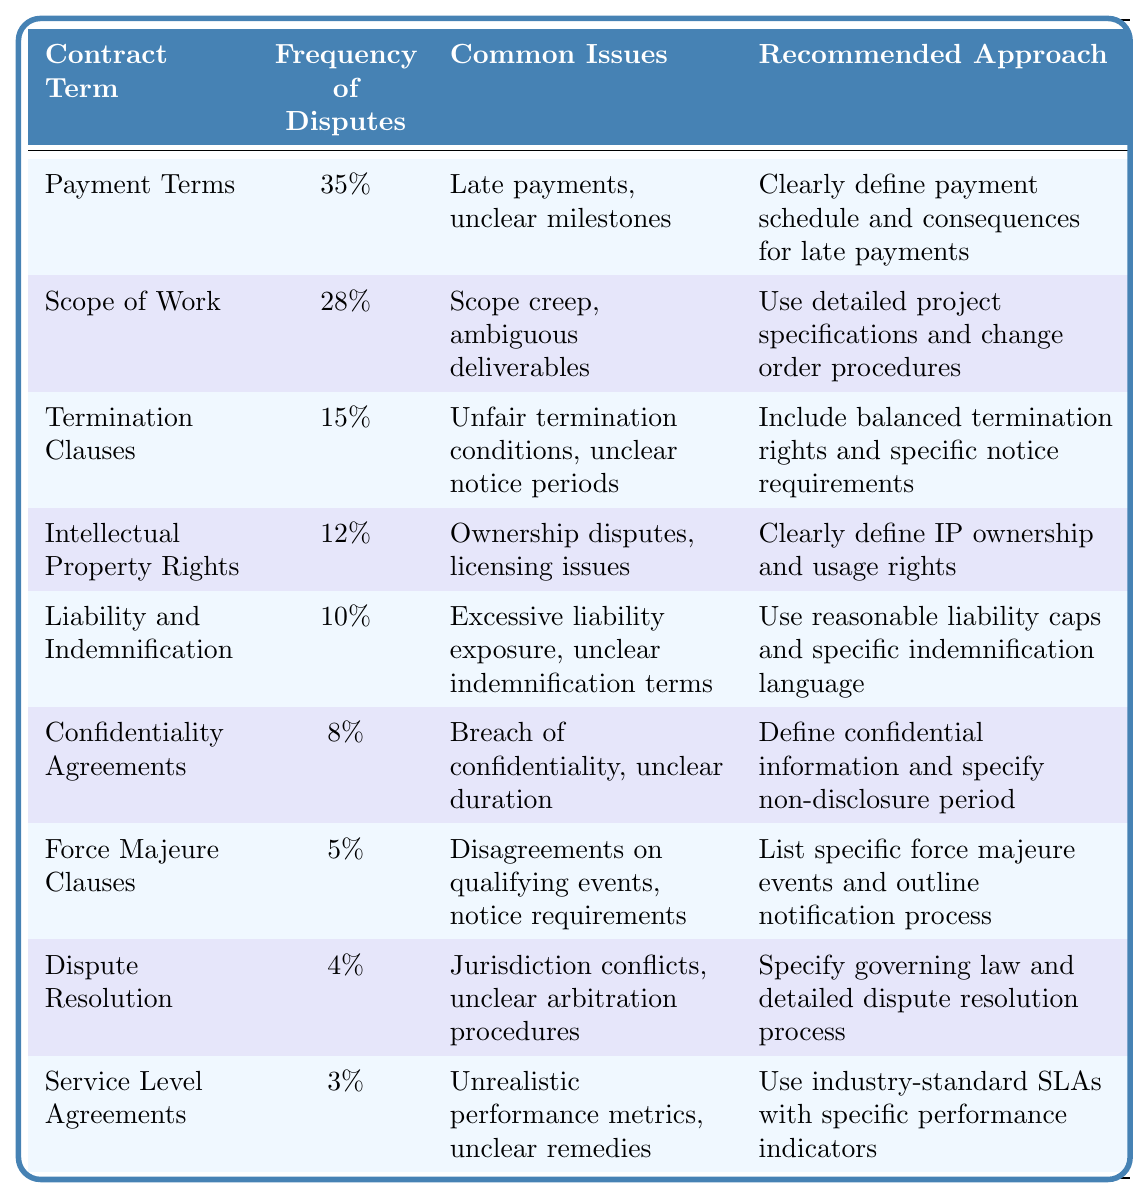What is the most frequently disputed contract term? The table indicates that "Payment Terms" have the highest frequency of disputes at 35%.
Answer: Payment Terms What percentage of disputes are related to Termination Clauses? The table shows that Termination Clauses account for 15% of disputes.
Answer: 15% Which contract term has the lowest frequency of disputes? The table reveals that "Service Level Agreements" has the lowest frequency with only 3%.
Answer: Service Level Agreements What are common issues with Scope of Work? According to the table, the common issues with Scope of Work include scope creep and ambiguous deliverables.
Answer: Scope creep, ambiguous deliverables What is the recommended approach for addressing Intellectual Property Rights disputes? The table recommends clearly defining IP ownership and usage rights to address disputes in this area.
Answer: Clearly define IP ownership and usage rights How do the disputes for Liability and Indemnification compare to those for Confidentiality Agreements? The disputes for Liability and Indemnification account for 10%, while Confidentiality Agreements account for 8%, indicating that Liability and Indemnification disputes are more frequent by 2%.
Answer: 2% more frequent If you sum the frequencies of disputes for all terms listed, what is the total? Adding the percentages: 35% + 28% + 15% + 12% + 10% + 8% + 5% + 4% + 3% equals 120%.
Answer: 120% Which contract term has a recommended approach that includes industry-standard SLAs? The table states that the recommended approach for "Service Level Agreements" includes using industry-standard SLAs with specific performance indicators.
Answer: Service Level Agreements Is the frequency of disputes for Force Majeure Clauses higher than that for Dispute Resolution? Yes, Force Majeure Clauses (5%) have a higher frequency of disputes compared to Dispute Resolution (4%).
Answer: Yes What is the difference in frequency of disputes between Payment Terms and Intellectual Property Rights? The difference is 35% (Payment Terms) - 12% (Intellectual Property Rights) = 23%.
Answer: 23% 